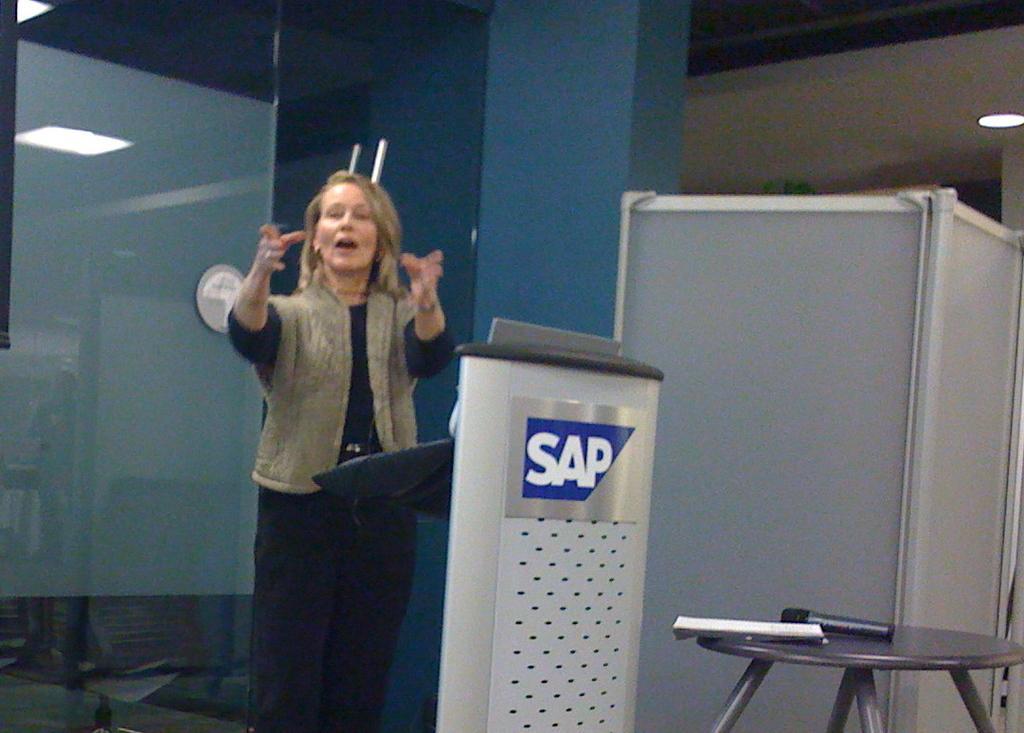Describe this image in one or two sentences. In the image we can see there is a woman standing and she is wearing jacket. The woman is standing near the podium and there is a mic and book kept on the table. There are lightings on the roof. 